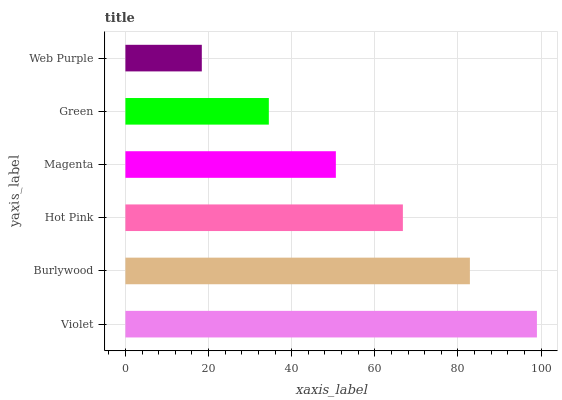Is Web Purple the minimum?
Answer yes or no. Yes. Is Violet the maximum?
Answer yes or no. Yes. Is Burlywood the minimum?
Answer yes or no. No. Is Burlywood the maximum?
Answer yes or no. No. Is Violet greater than Burlywood?
Answer yes or no. Yes. Is Burlywood less than Violet?
Answer yes or no. Yes. Is Burlywood greater than Violet?
Answer yes or no. No. Is Violet less than Burlywood?
Answer yes or no. No. Is Hot Pink the high median?
Answer yes or no. Yes. Is Magenta the low median?
Answer yes or no. Yes. Is Violet the high median?
Answer yes or no. No. Is Burlywood the low median?
Answer yes or no. No. 